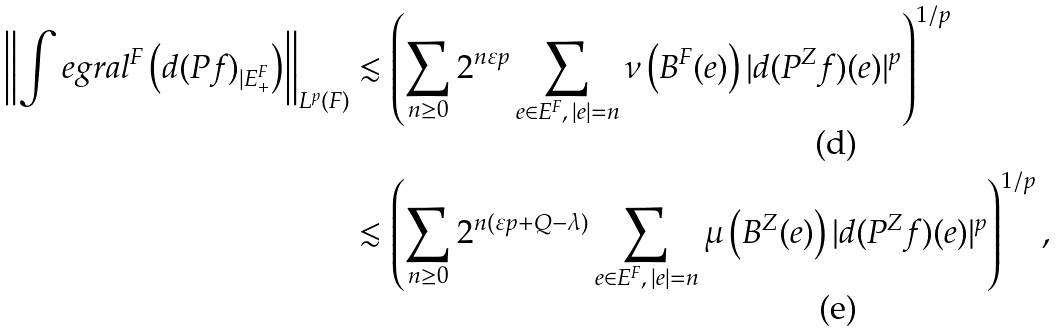<formula> <loc_0><loc_0><loc_500><loc_500>\left \| \int e g r a l ^ { F } \left ( d ( P f ) _ { | E ^ { F } _ { + } } \right ) \right \| _ { L ^ { p } ( F ) } & \lesssim \left ( \sum _ { n \geq 0 } 2 ^ { n \varepsilon p } \sum _ { e \in E ^ { F } , \, | e | = n } \nu \left ( B ^ { F } ( e ) \right ) | d ( P ^ { Z } f ) ( e ) | ^ { p } \right ) ^ { 1 / p } \\ & \lesssim \left ( \sum _ { n \geq 0 } 2 ^ { n ( \varepsilon p + Q - \lambda ) } \sum _ { e \in E ^ { F } , \, | e | = n } \mu \left ( B ^ { Z } ( e ) \right ) | d ( P ^ { Z } f ) ( e ) | ^ { p } \right ) ^ { 1 / p } ,</formula> 